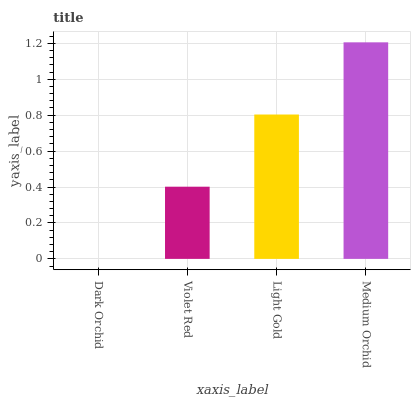Is Dark Orchid the minimum?
Answer yes or no. Yes. Is Medium Orchid the maximum?
Answer yes or no. Yes. Is Violet Red the minimum?
Answer yes or no. No. Is Violet Red the maximum?
Answer yes or no. No. Is Violet Red greater than Dark Orchid?
Answer yes or no. Yes. Is Dark Orchid less than Violet Red?
Answer yes or no. Yes. Is Dark Orchid greater than Violet Red?
Answer yes or no. No. Is Violet Red less than Dark Orchid?
Answer yes or no. No. Is Light Gold the high median?
Answer yes or no. Yes. Is Violet Red the low median?
Answer yes or no. Yes. Is Dark Orchid the high median?
Answer yes or no. No. Is Dark Orchid the low median?
Answer yes or no. No. 